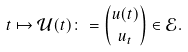Convert formula to latex. <formula><loc_0><loc_0><loc_500><loc_500>t \mapsto \mathcal { U } ( t ) \colon = \binom { u ( t ) } { u _ { t } } \in \mathcal { E } .</formula> 